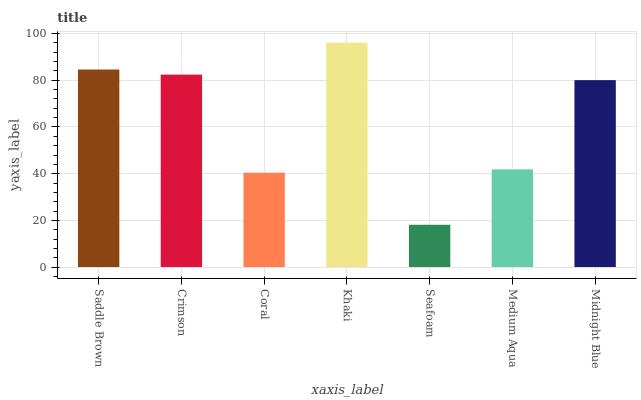Is Seafoam the minimum?
Answer yes or no. Yes. Is Khaki the maximum?
Answer yes or no. Yes. Is Crimson the minimum?
Answer yes or no. No. Is Crimson the maximum?
Answer yes or no. No. Is Saddle Brown greater than Crimson?
Answer yes or no. Yes. Is Crimson less than Saddle Brown?
Answer yes or no. Yes. Is Crimson greater than Saddle Brown?
Answer yes or no. No. Is Saddle Brown less than Crimson?
Answer yes or no. No. Is Midnight Blue the high median?
Answer yes or no. Yes. Is Midnight Blue the low median?
Answer yes or no. Yes. Is Crimson the high median?
Answer yes or no. No. Is Saddle Brown the low median?
Answer yes or no. No. 